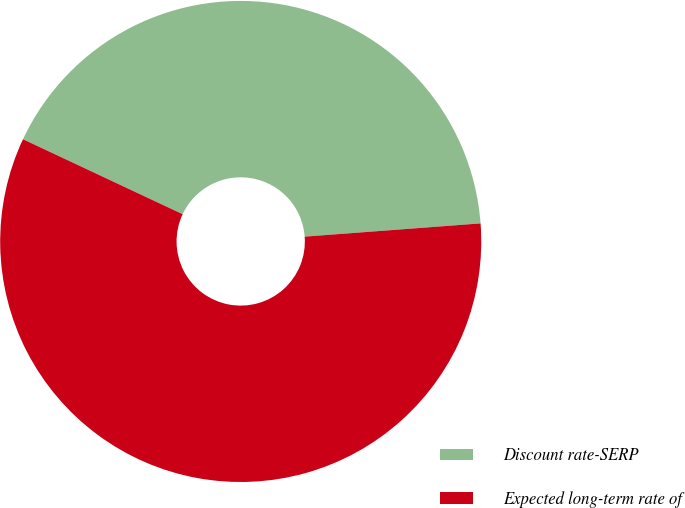Convert chart. <chart><loc_0><loc_0><loc_500><loc_500><pie_chart><fcel>Discount rate-SERP<fcel>Expected long-term rate of<nl><fcel>41.82%<fcel>58.18%<nl></chart> 